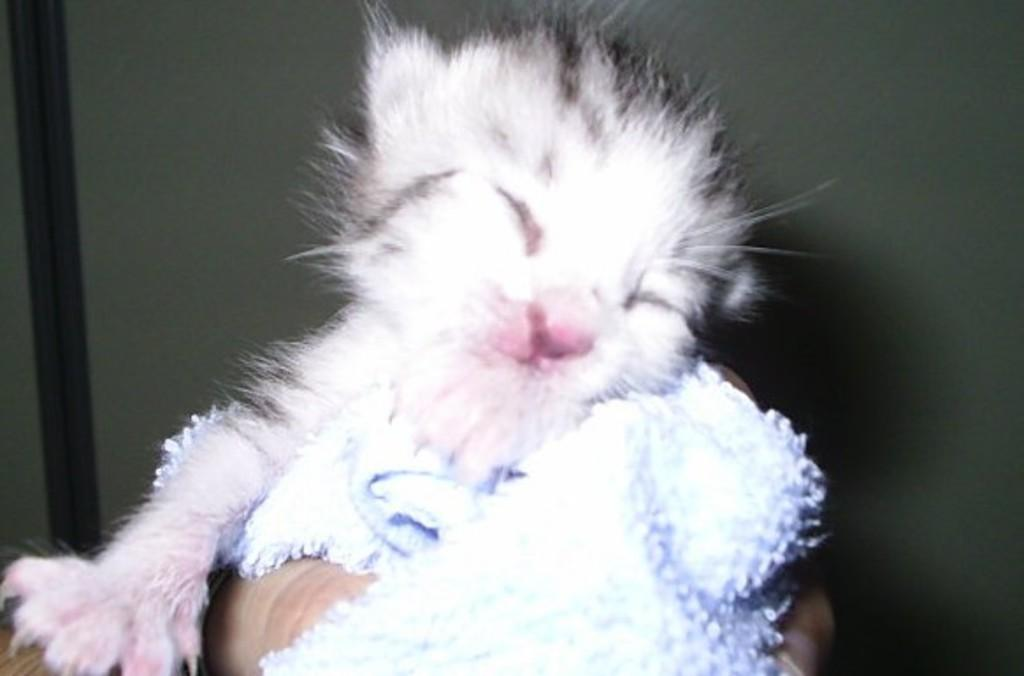What type of animal is in the image? There is a cat in the image. What part of a person is visible in the image? A person's hand is visible in the image. What material is present in the image? There is cloth in the image. What colors are present in the background of the image? The background of the image is grey and black. What type of truck is visible in the image? There is no truck present in the image. How many trees are visible in the image? There are no trees present in the image. 